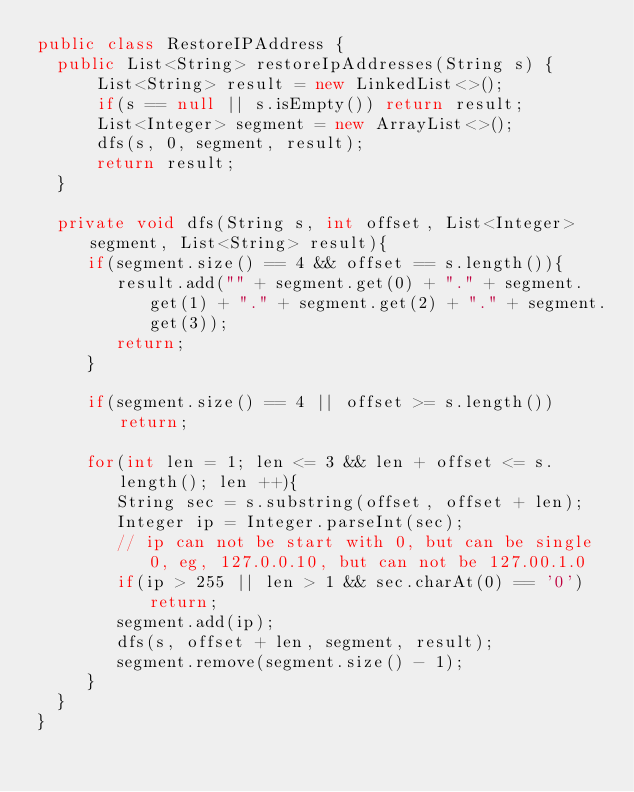Convert code to text. <code><loc_0><loc_0><loc_500><loc_500><_Java_>public class RestoreIPAddress {
	public List<String> restoreIpAddresses(String s) {
	    List<String> result = new LinkedList<>();
	    if(s == null || s.isEmpty()) return result;
	    List<Integer> segment = new ArrayList<>();
	    dfs(s, 0, segment, result);
	    return result;
	}

	private void dfs(String s, int offset, List<Integer> segment, List<String> result){
	   if(segment.size() == 4 && offset == s.length()){
	   		result.add("" + segment.get(0) + "." + segment.get(1) + "." + segment.get(2) + "." + segment.get(3));
	   		return;
	   }

	   if(segment.size() == 4 || offset >= s.length()) return;

	   for(int len = 1; len <= 3 && len + offset <= s.length(); len ++){
	   		String sec = s.substring(offset, offset + len);
	   		Integer ip = Integer.parseInt(sec);
	   		// ip can not be start with 0, but can be single 0, eg, 127.0.0.10, but can not be 127.00.1.0
	   		if(ip > 255 || len > 1 && sec.charAt(0) == '0') return;
	   		segment.add(ip);
	   		dfs(s, offset + len, segment, result);
	   		segment.remove(segment.size() - 1);
	   }
	}
}</code> 